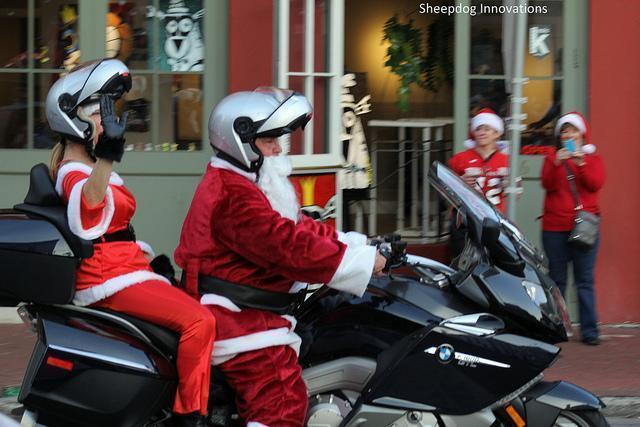Who is riding on the motorcycle?
Select the accurate answer and provide justification: `Answer: choice
Rationale: srationale.`
Options: Easter bunny, freddy krueger, jason vorhees, santa claus. Answer: santa claus.
Rationale: Santa claus is known for dressing in a red suit and wearing a long white beard. 